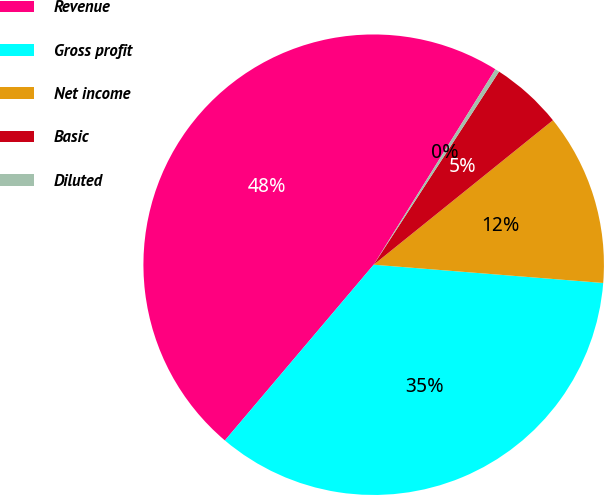<chart> <loc_0><loc_0><loc_500><loc_500><pie_chart><fcel>Revenue<fcel>Gross profit<fcel>Net income<fcel>Basic<fcel>Diluted<nl><fcel>47.69%<fcel>34.92%<fcel>12.06%<fcel>5.04%<fcel>0.3%<nl></chart> 